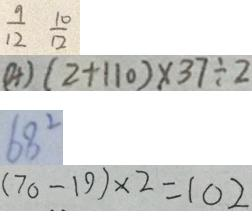Convert formula to latex. <formula><loc_0><loc_0><loc_500><loc_500>\frac { 9 } { 1 2 } \frac { 1 0 } { 1 2 } 
 ( 4 ) ( 2 + 1 1 0 ) \times 3 7 \div 2 
 6 8 ^ { 2 } 
 ( 7 0 - 1 9 ) \times 2 = 1 0 2</formula> 